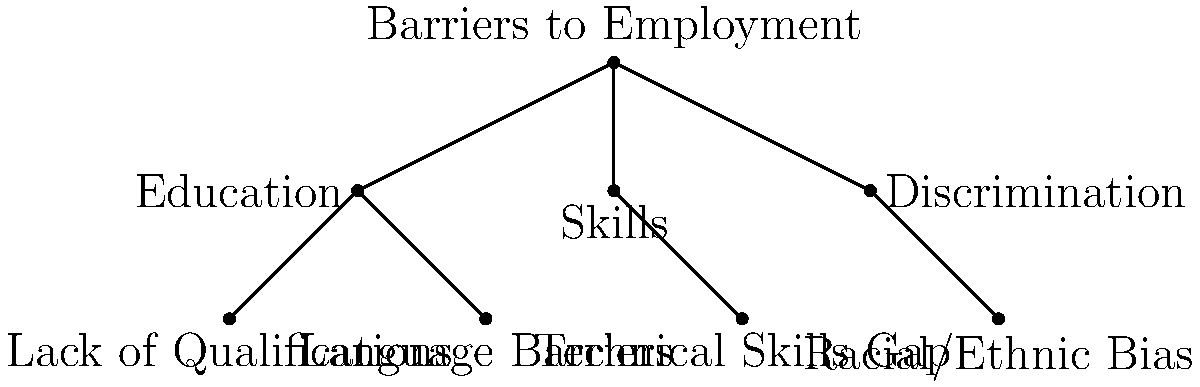Based on the tree diagram illustrating barriers to employment, which category of barriers has the most direct sub-categories, and how many does it have? To answer this question, we need to analyze the hierarchical structure of the tree diagram:

1. The main node at the top represents "Barriers to Employment".

2. There are three main categories branching from the top:
   - Education (left branch)
   - Skills (middle branch)
   - Discrimination (right branch)

3. Let's count the direct sub-categories for each main category:
   - Education: Has 2 sub-categories (Lack of Qualifications, Language Barriers)
   - Skills: Has 1 sub-category (Technical Skills Gap)
   - Discrimination: Has 1 sub-category (Racial/Ethnic Bias)

4. Comparing the number of sub-categories:
   - Education: 2
   - Skills: 1
   - Discrimination: 1

5. We can conclude that Education has the most direct sub-categories with 2.
Answer: Education, 2 